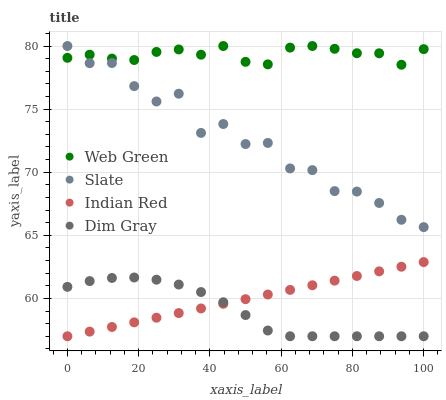Does Dim Gray have the minimum area under the curve?
Answer yes or no. Yes. Does Web Green have the maximum area under the curve?
Answer yes or no. Yes. Does Indian Red have the minimum area under the curve?
Answer yes or no. No. Does Indian Red have the maximum area under the curve?
Answer yes or no. No. Is Indian Red the smoothest?
Answer yes or no. Yes. Is Slate the roughest?
Answer yes or no. Yes. Is Dim Gray the smoothest?
Answer yes or no. No. Is Dim Gray the roughest?
Answer yes or no. No. Does Dim Gray have the lowest value?
Answer yes or no. Yes. Does Web Green have the lowest value?
Answer yes or no. No. Does Web Green have the highest value?
Answer yes or no. Yes. Does Indian Red have the highest value?
Answer yes or no. No. Is Dim Gray less than Slate?
Answer yes or no. Yes. Is Slate greater than Dim Gray?
Answer yes or no. Yes. Does Dim Gray intersect Indian Red?
Answer yes or no. Yes. Is Dim Gray less than Indian Red?
Answer yes or no. No. Is Dim Gray greater than Indian Red?
Answer yes or no. No. Does Dim Gray intersect Slate?
Answer yes or no. No. 